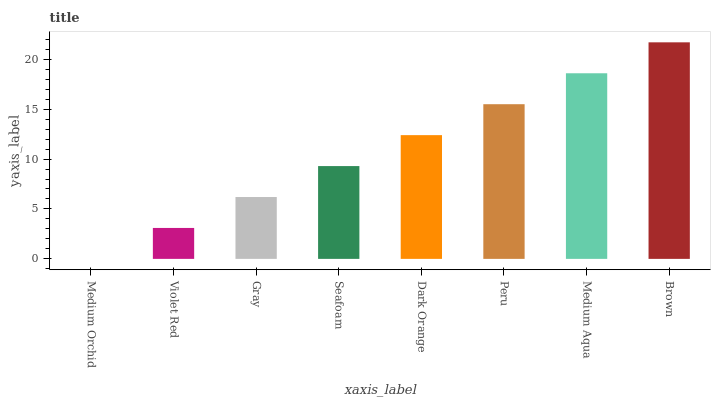Is Violet Red the minimum?
Answer yes or no. No. Is Violet Red the maximum?
Answer yes or no. No. Is Violet Red greater than Medium Orchid?
Answer yes or no. Yes. Is Medium Orchid less than Violet Red?
Answer yes or no. Yes. Is Medium Orchid greater than Violet Red?
Answer yes or no. No. Is Violet Red less than Medium Orchid?
Answer yes or no. No. Is Dark Orange the high median?
Answer yes or no. Yes. Is Seafoam the low median?
Answer yes or no. Yes. Is Medium Aqua the high median?
Answer yes or no. No. Is Peru the low median?
Answer yes or no. No. 